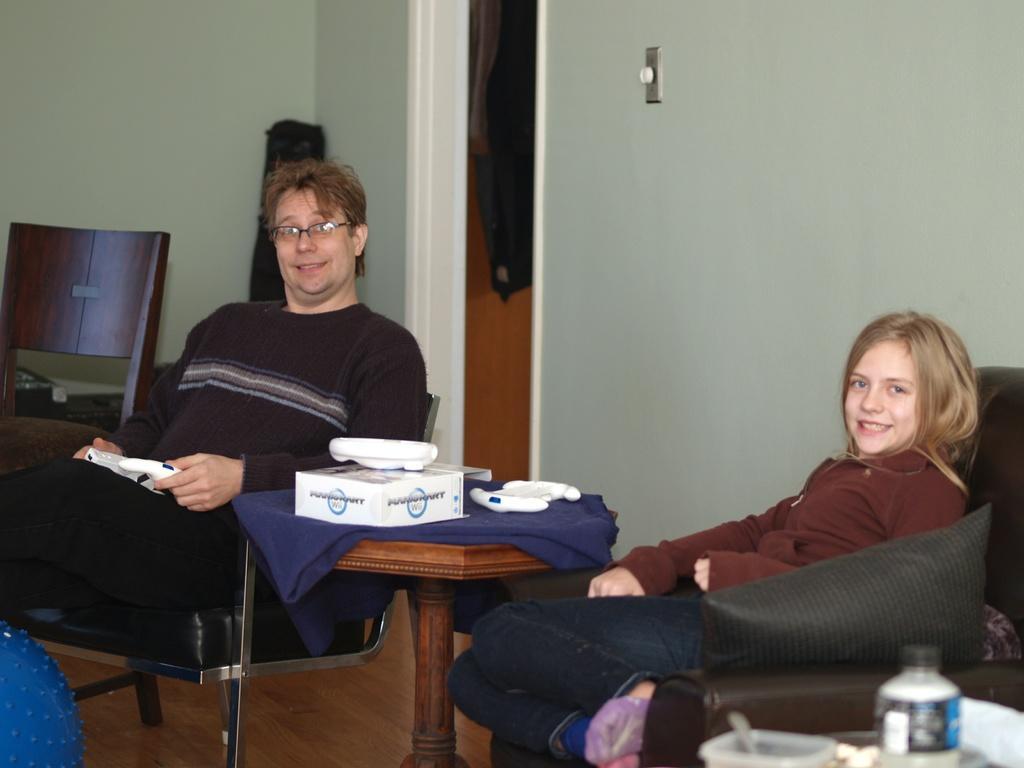Can you describe this image briefly? In this picture we can see man and girl sitting on chairs and sofa with pillows on it and in between them we have table and on table box, cloth and in background we can see wall, chair. 